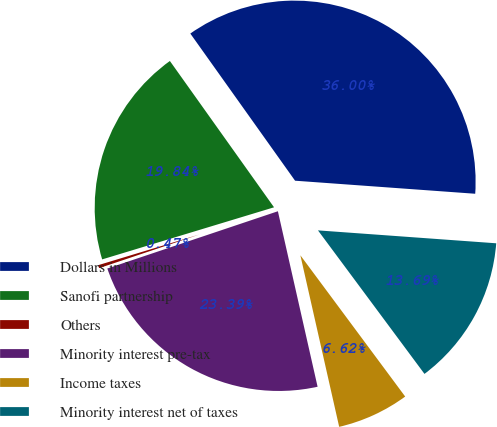<chart> <loc_0><loc_0><loc_500><loc_500><pie_chart><fcel>Dollars in Millions<fcel>Sanofi partnership<fcel>Others<fcel>Minority interest pre-tax<fcel>Income taxes<fcel>Minority interest net of taxes<nl><fcel>36.0%<fcel>19.84%<fcel>0.47%<fcel>23.39%<fcel>6.62%<fcel>13.69%<nl></chart> 